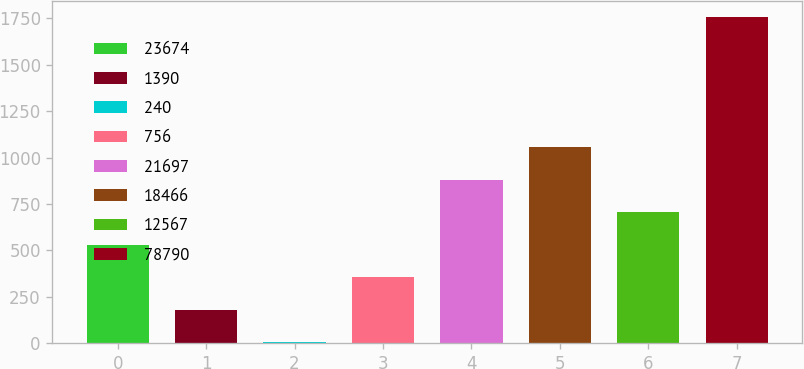<chart> <loc_0><loc_0><loc_500><loc_500><bar_chart><fcel>23674<fcel>1390<fcel>240<fcel>756<fcel>21697<fcel>18466<fcel>12567<fcel>78790<nl><fcel>531.17<fcel>180.59<fcel>5.3<fcel>355.88<fcel>881.75<fcel>1057.04<fcel>706.46<fcel>1758.2<nl></chart> 